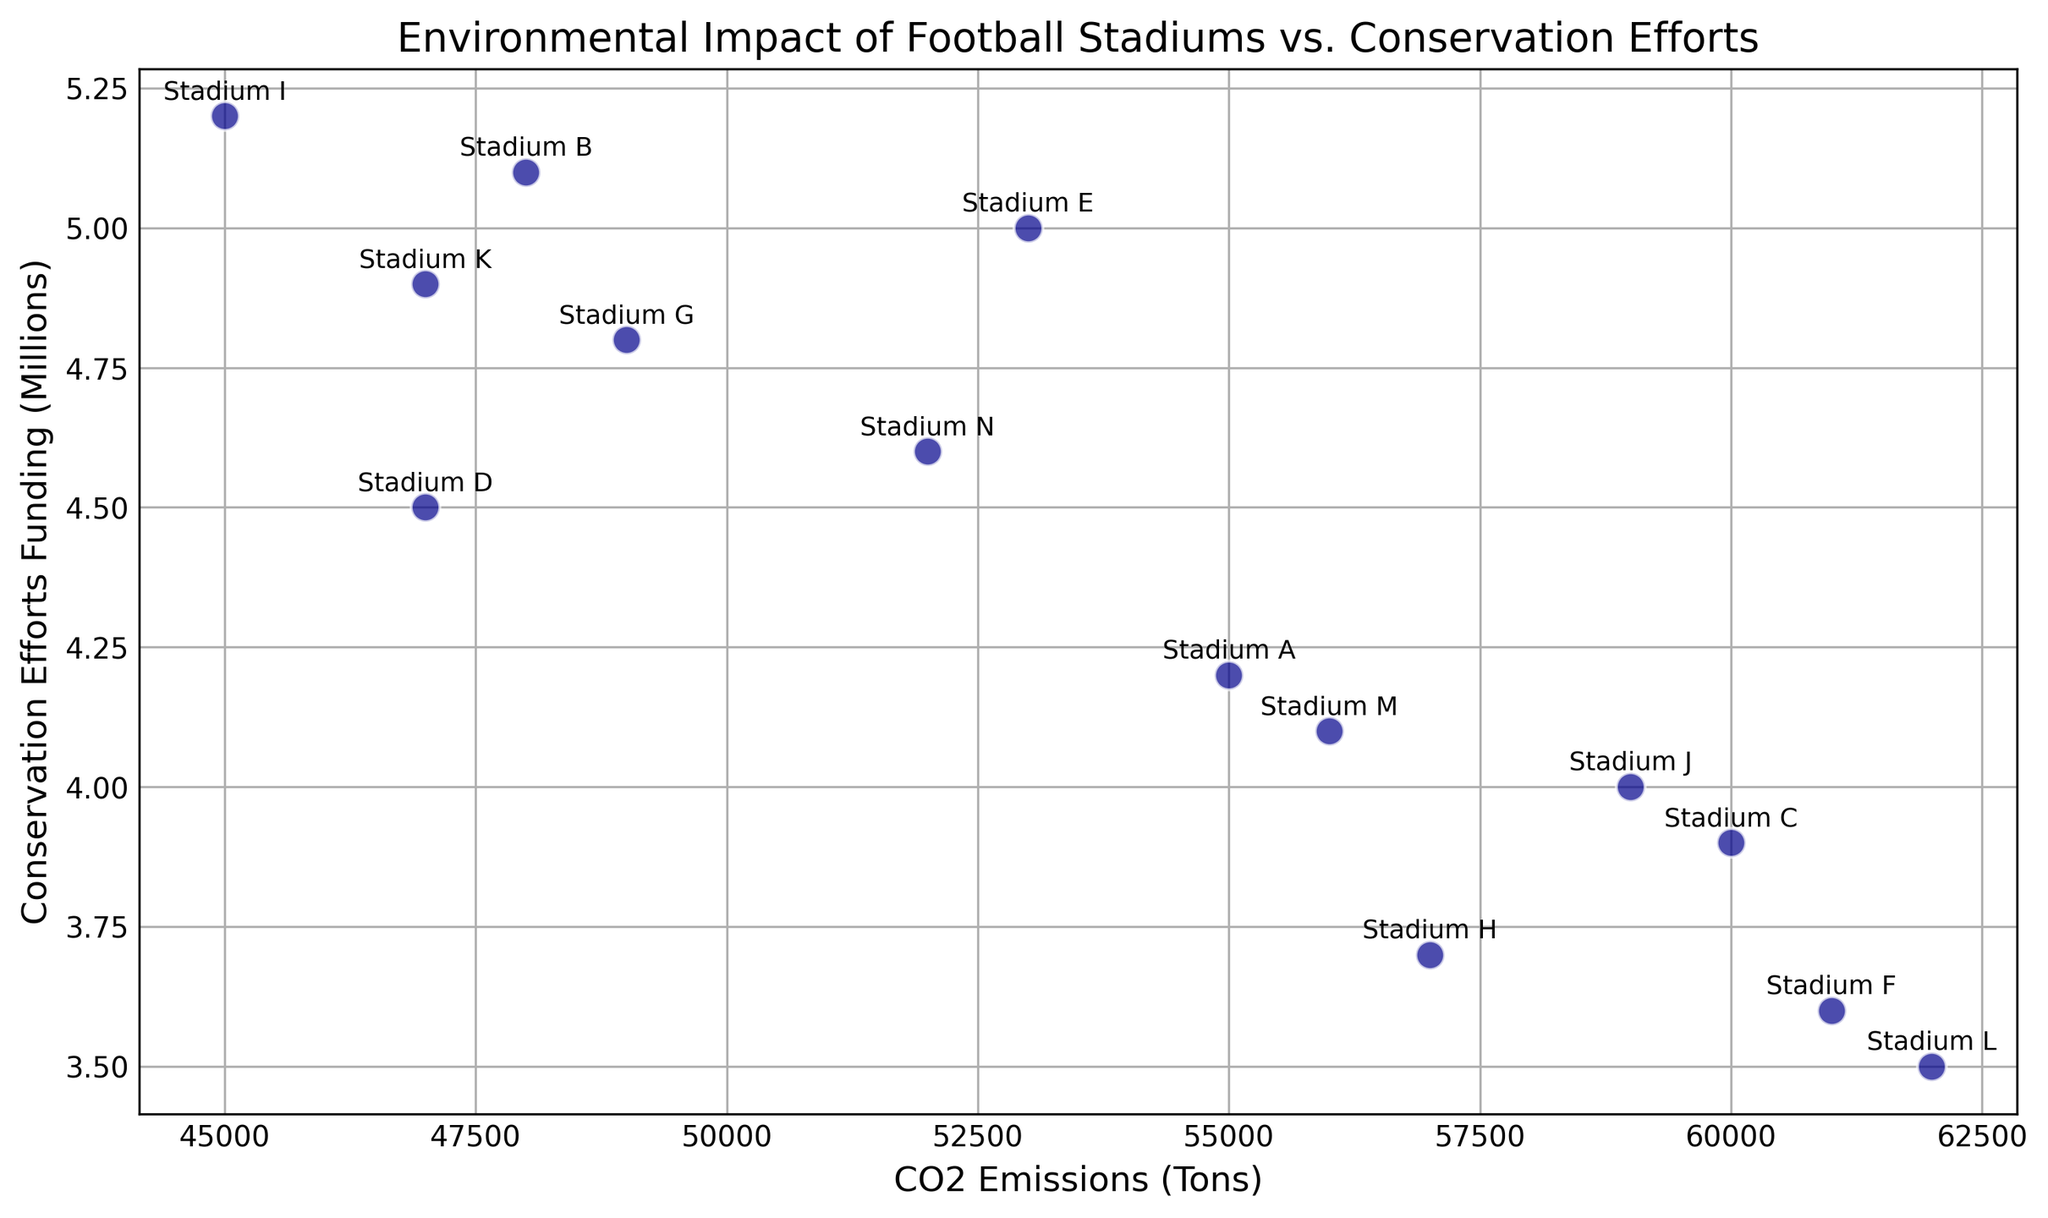Which stadium has the highest CO2 emissions? Look for the stadium with the highest point along the x-axis (CO2 Emissions)
Answer: Stadium L Which stadium has the lowest CO2 emissions? Identify the stadium with the lowest point along the x-axis (CO2 Emissions)
Answer: Stadium I Which stadium has the most funding for conservation efforts? Look for the stadium with the highest point along the y-axis (Conservation Efforts Funding)
Answer: Stadium I What is the difference in CO2 emissions between Stadium A and Stadium C? Subtract the CO2 emissions of Stadium A from Stadium C. 60000 - 55000 = 5000
Answer: 5000 tons Is there a general trend between CO2 emissions and conservation efforts funding? Observe the scatter plot for any patterns or correlations between the x-axis (CO2 Emissions) and the y-axis (Conservation Efforts Funding). The points do not show a clear correlation, indicating a lack of direct relationship
Answer: No clear trend What are the average CO2 emissions and conservation efforts funding? Calculate the mean of the CO2 emissions and the mean of the conservation efforts funding from the dataset:
Mean CO2 = (55000 + 48000 + 60000 + 47000 + 53000 + 61000 + 49000 + 57000 + 45000 + 59000 + 47000 + 62000 + 56000 + 52000) / 14 = 53428.57 tons.
Mean Conservation Efforts Funding = (4.2 + 5.1 + 3.9 + 4.5 + 5.0 + 3.6 + 4.8 + 3.7 + 5.2 + 4.0 + 4.9 + 3.5 + 4.1 + 4.6) / 14 = 4.343 million.
Answer: 53428.57 tons, 4.343 million Are there any stadiums with both high CO2 emissions and high conservation efforts funding? Look for points that are high on the x-axis (indicating high CO2 emissions) and high on the y-axis (indicating high conservation efforts funding). No single point stands out in both categories; Stadium C has high CO2 emissions but only moderate conservation funding
Answer: No Which stadiums have CO2 emissions greater than 55000 tons and conservation efforts funding greater than 4 million? Identify points that lie to the right of 55000 on the x-axis and above 4 on the y-axis. Stadium A and Stadium N meet these criteria
Answer: Stadium A, Stadium N 